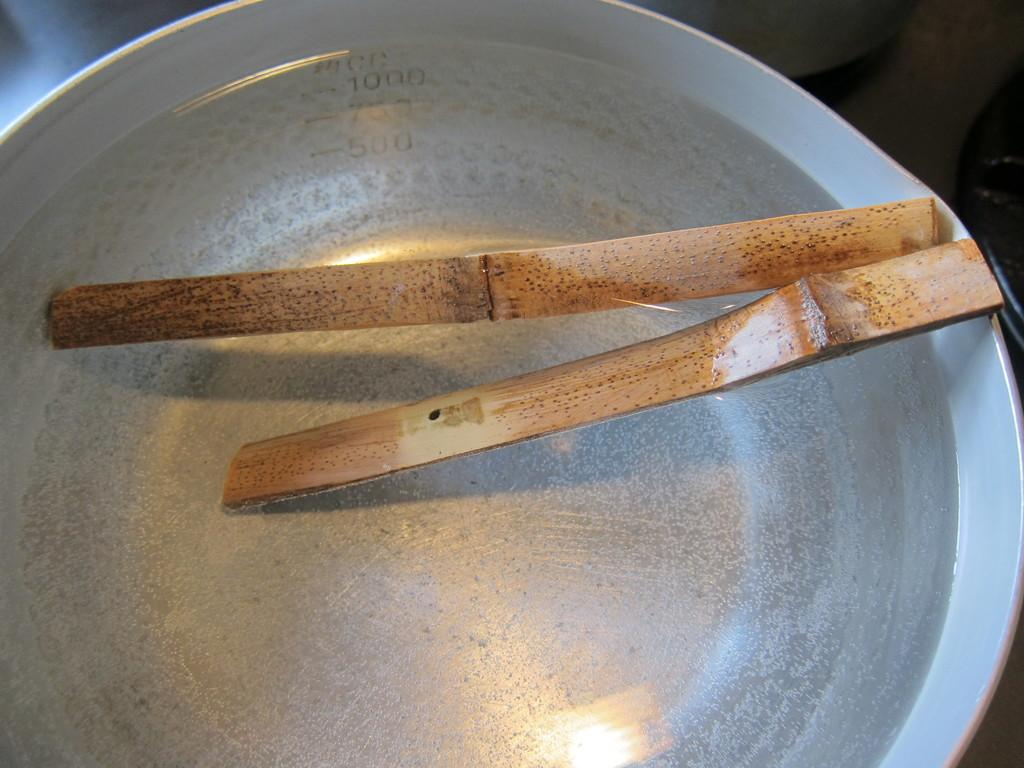What is the color of the bowl in the image? The bowl in the image is silver. What objects are inside the bowl? There are two wooden sticks in the bowl. What type of fruit is present in the image? There is no fruit present in the image; it only features a silver bowl with two wooden sticks. 